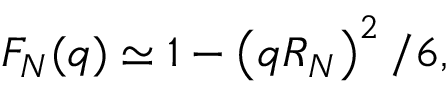Convert formula to latex. <formula><loc_0><loc_0><loc_500><loc_500>F _ { N } ( q ) \simeq 1 - \left ( q R _ { N } \right ) ^ { 2 } / 6 ,</formula> 